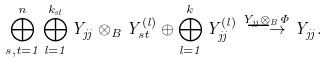Convert formula to latex. <formula><loc_0><loc_0><loc_500><loc_500>\bigoplus _ { s , t = 1 } ^ { n } \bigoplus _ { l = 1 } ^ { k _ { s t } } Y _ { j j } \otimes _ { B } Y _ { s t } ^ { ( l ) } \oplus \bigoplus _ { l = 1 } ^ { k } Y _ { j j } ^ { ( l ) } \overset { Y _ { j j } \otimes _ { B } \Phi } { \longrightarrow } Y _ { j j } .</formula> 